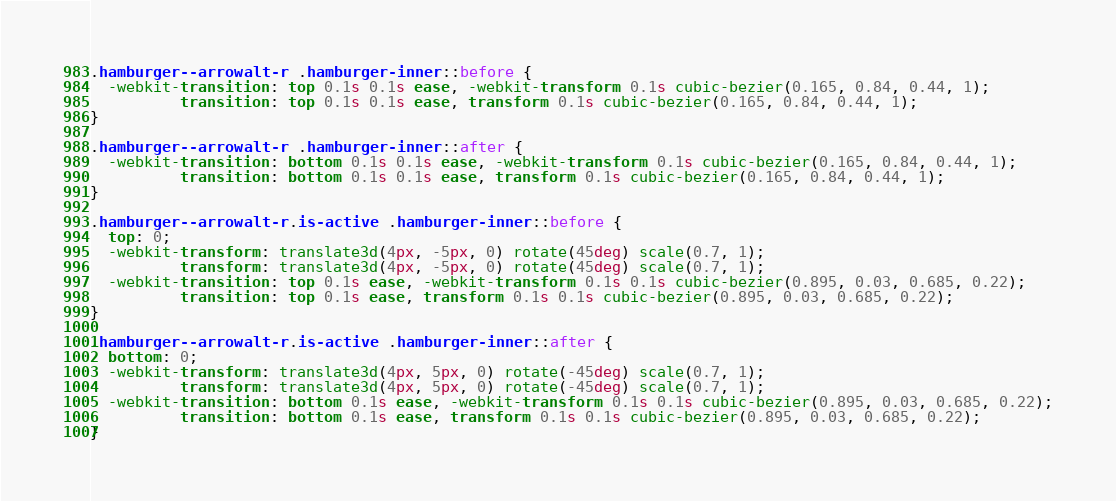<code> <loc_0><loc_0><loc_500><loc_500><_CSS_>.hamburger--arrowalt-r .hamburger-inner::before {
  -webkit-transition: top 0.1s 0.1s ease, -webkit-transform 0.1s cubic-bezier(0.165, 0.84, 0.44, 1);
          transition: top 0.1s 0.1s ease, transform 0.1s cubic-bezier(0.165, 0.84, 0.44, 1);
}

.hamburger--arrowalt-r .hamburger-inner::after {
  -webkit-transition: bottom 0.1s 0.1s ease, -webkit-transform 0.1s cubic-bezier(0.165, 0.84, 0.44, 1);
          transition: bottom 0.1s 0.1s ease, transform 0.1s cubic-bezier(0.165, 0.84, 0.44, 1);
}

.hamburger--arrowalt-r.is-active .hamburger-inner::before {
  top: 0;
  -webkit-transform: translate3d(4px, -5px, 0) rotate(45deg) scale(0.7, 1);
          transform: translate3d(4px, -5px, 0) rotate(45deg) scale(0.7, 1);
  -webkit-transition: top 0.1s ease, -webkit-transform 0.1s 0.1s cubic-bezier(0.895, 0.03, 0.685, 0.22);
          transition: top 0.1s ease, transform 0.1s 0.1s cubic-bezier(0.895, 0.03, 0.685, 0.22);
}

.hamburger--arrowalt-r.is-active .hamburger-inner::after {
  bottom: 0;
  -webkit-transform: translate3d(4px, 5px, 0) rotate(-45deg) scale(0.7, 1);
          transform: translate3d(4px, 5px, 0) rotate(-45deg) scale(0.7, 1);
  -webkit-transition: bottom 0.1s ease, -webkit-transform 0.1s 0.1s cubic-bezier(0.895, 0.03, 0.685, 0.22);
          transition: bottom 0.1s ease, transform 0.1s 0.1s cubic-bezier(0.895, 0.03, 0.685, 0.22);
}</code> 